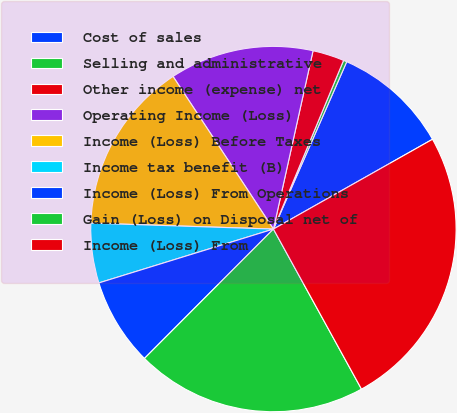<chart> <loc_0><loc_0><loc_500><loc_500><pie_chart><fcel>Cost of sales<fcel>Selling and administrative<fcel>Other income (expense) net<fcel>Operating Income (Loss)<fcel>Income (Loss) Before Taxes<fcel>Income tax benefit (B)<fcel>Income (Loss) From Operations<fcel>Gain (Loss) on Disposal net of<fcel>Income (Loss) From<nl><fcel>10.25%<fcel>0.3%<fcel>2.79%<fcel>12.74%<fcel>15.22%<fcel>5.28%<fcel>7.76%<fcel>20.48%<fcel>25.17%<nl></chart> 